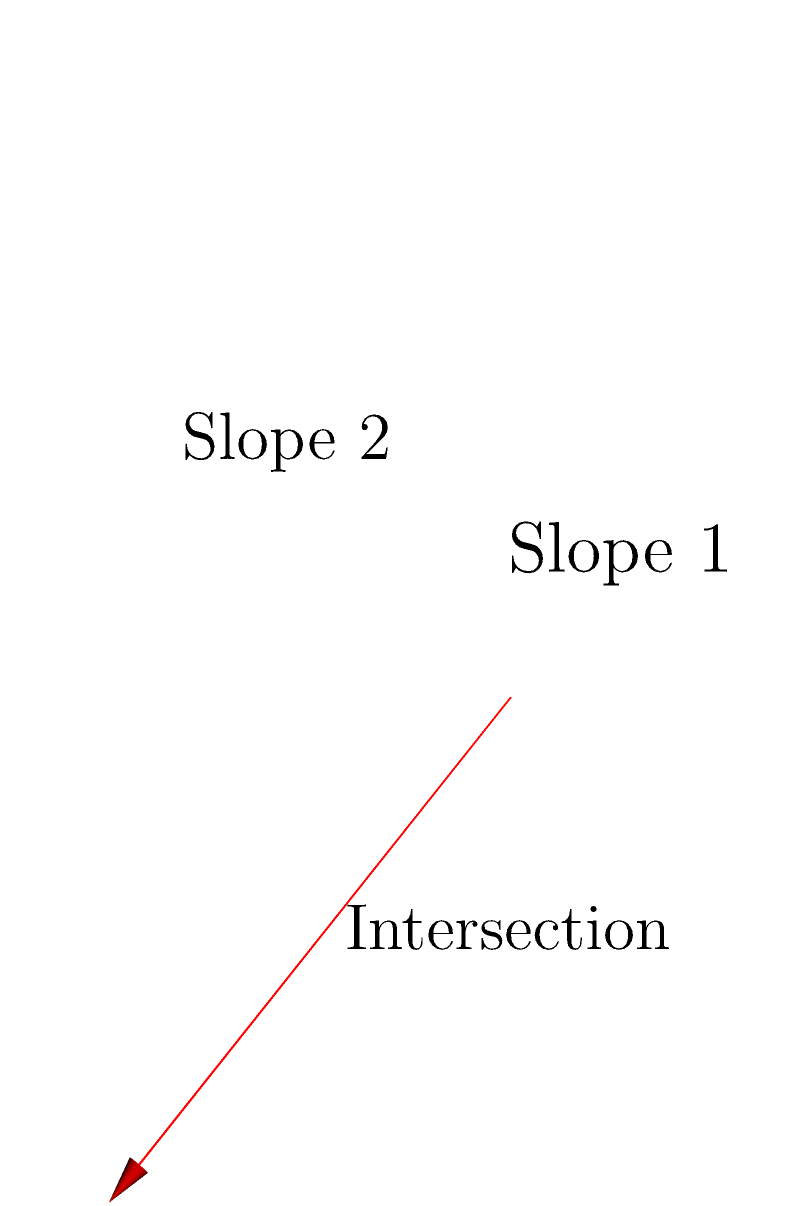As you're planning an epic snowboarding run, you come across two intersecting ski slopes. The normal vector of the first slope is $\vec{n_1} = (1,1,1)$, and the normal vector of the second slope is $\vec{n_2} = (1,-1,2)$. What is the angle between these two slopes? Let's approach this step-by-step:

1) The angle between two planes is the same as the angle between their normal vectors.

2) To find the angle between two vectors, we use the dot product formula:

   $$\cos \theta = \frac{\vec{n_1} \cdot \vec{n_2}}{|\vec{n_1}||\vec{n_2}|}$$

3) Let's calculate the dot product $\vec{n_1} \cdot \vec{n_2}$:
   $$(1,1,1) \cdot (1,-1,2) = 1(1) + 1(-1) + 1(2) = 2$$

4) Now, let's calculate the magnitudes:
   $$|\vec{n_1}| = \sqrt{1^2 + 1^2 + 1^2} = \sqrt{3}$$
   $$|\vec{n_2}| = \sqrt{1^2 + (-1)^2 + 2^2} = \sqrt{6}$$

5) Substituting into the formula:

   $$\cos \theta = \frac{2}{\sqrt{3}\sqrt{6}} = \frac{2}{\sqrt{18}} = \frac{\sqrt{2}}{\sqrt{9}} = \frac{\sqrt{2}}{3}$$

6) To get the angle, we need to take the inverse cosine (arccos):

   $$\theta = \arccos(\frac{\sqrt{2}}{3})$$

7) This gives us approximately 0.9553 radians or 54.74 degrees.
Answer: 54.74° 